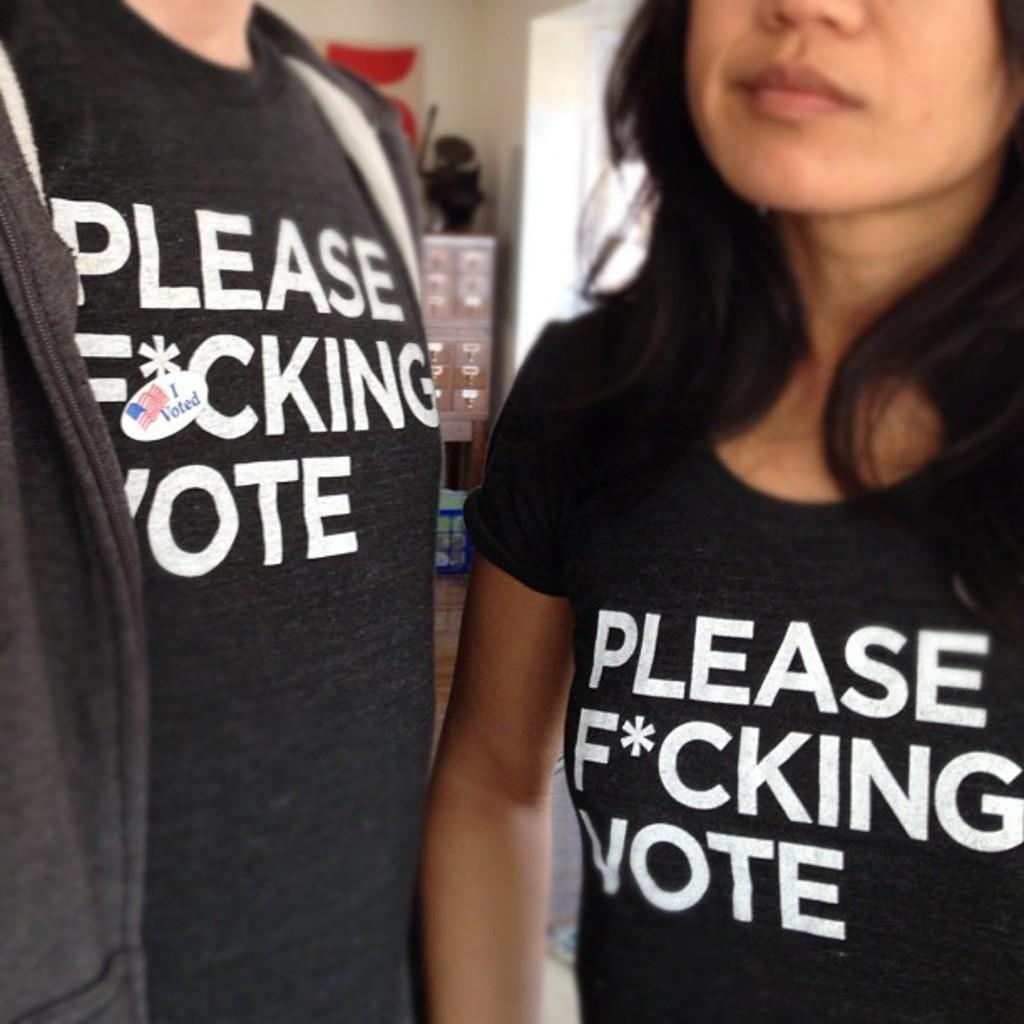Provide a one-sentence caption for the provided image. Shirts that are telling you to definetly vote. 